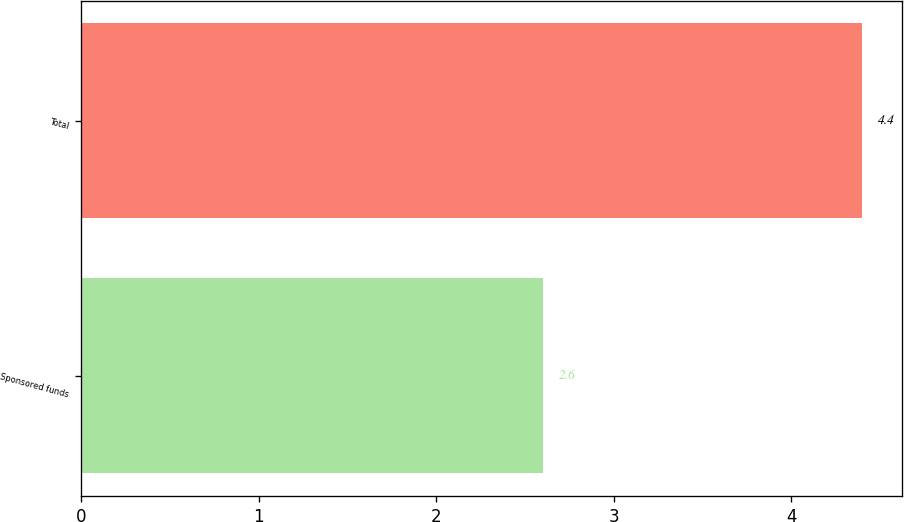Convert chart to OTSL. <chart><loc_0><loc_0><loc_500><loc_500><bar_chart><fcel>Sponsored funds<fcel>Total<nl><fcel>2.6<fcel>4.4<nl></chart> 